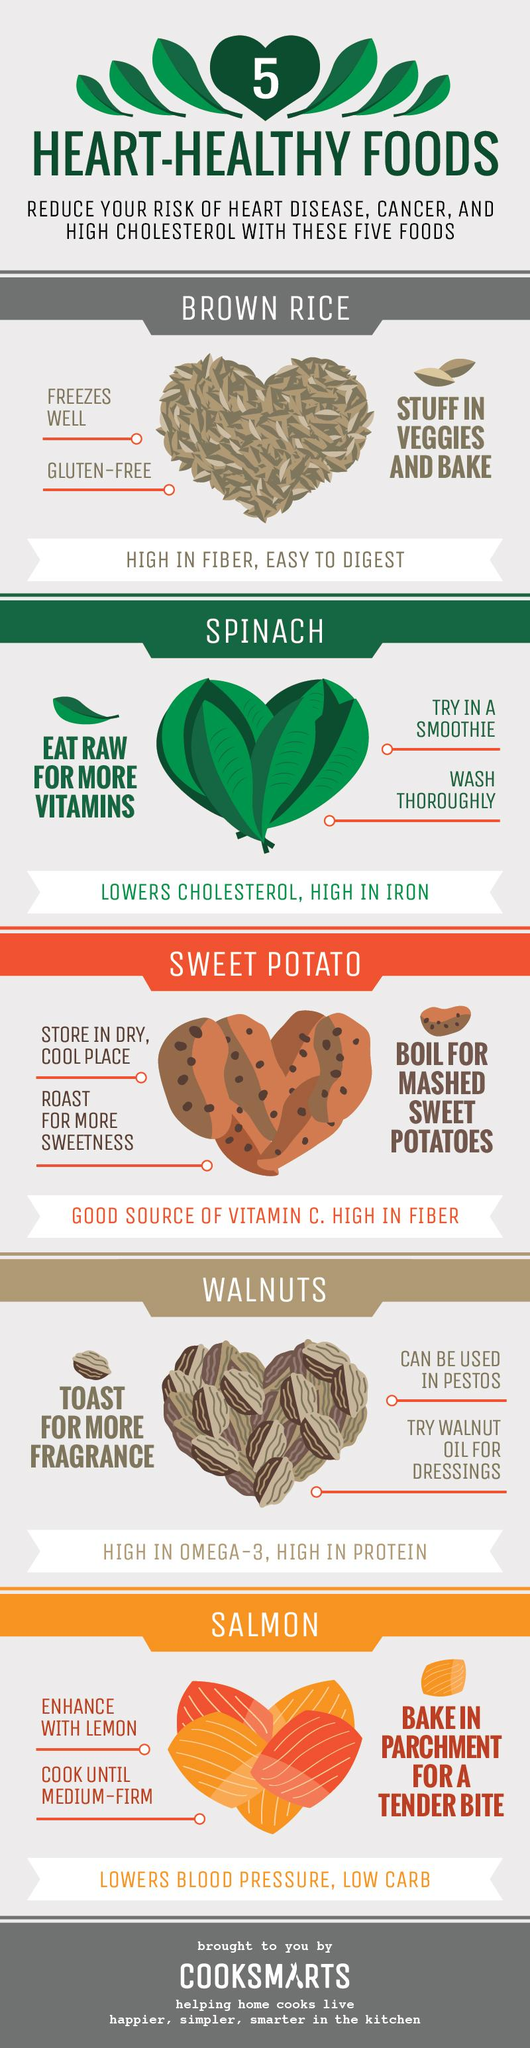Give some essential details in this illustration. There are various foods that are abundant in fiber, including sweet potatoes and brown rice. The list of heart-healthy foods contains sweet potato, walnuts, and salmon as its last three items. The food item mentioned in the third sub-heading is sweet potato. The first two items on the list of heart-healthy foods are brown rice and spinach. The food item given in the second sub-heading is spinach. 